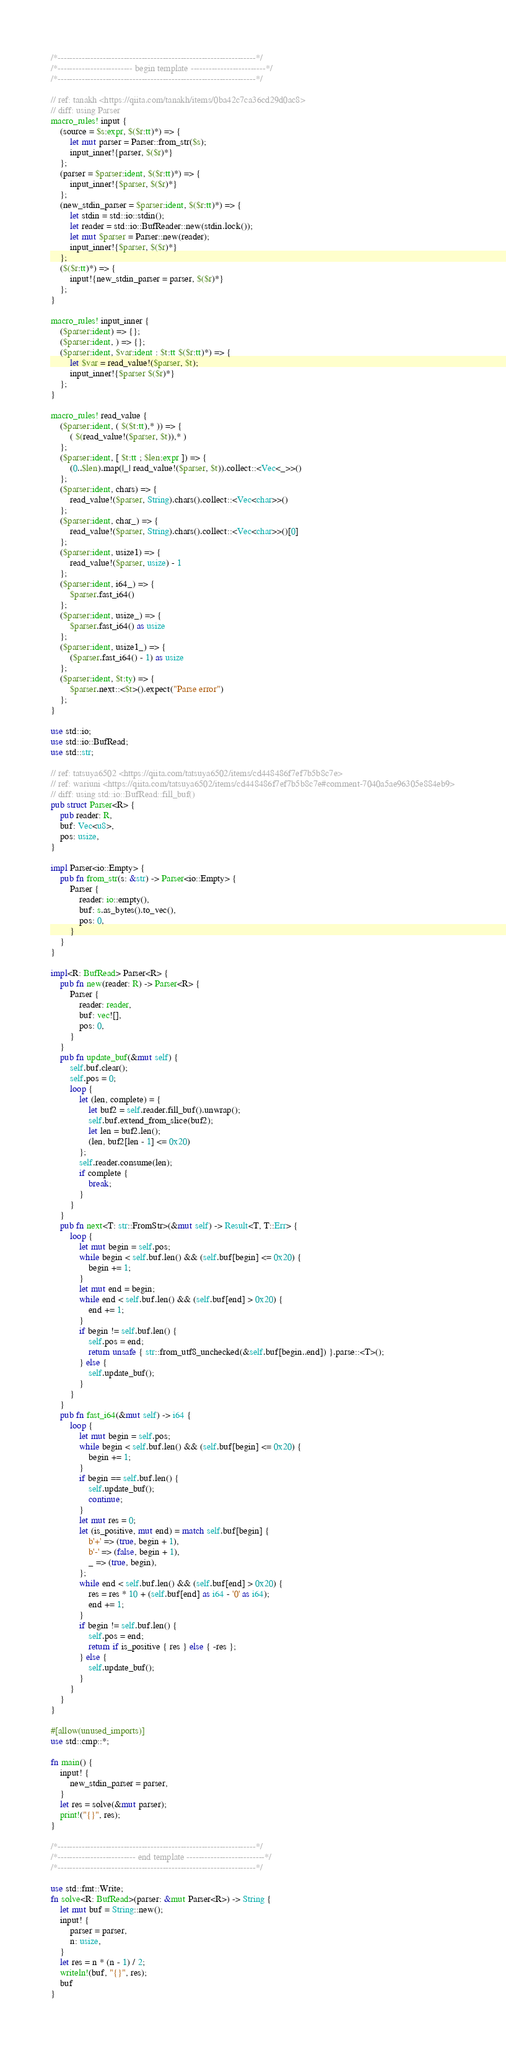Convert code to text. <code><loc_0><loc_0><loc_500><loc_500><_Rust_>/*------------------------------------------------------------------*/
/*------------------------- begin template -------------------------*/
/*------------------------------------------------------------------*/

// ref: tanakh <https://qiita.com/tanakh/items/0ba42c7ca36cd29d0ac8>
// diff: using Parser
macro_rules! input {
    (source = $s:expr, $($r:tt)*) => {
        let mut parser = Parser::from_str($s);
        input_inner!{parser, $($r)*}
    };
    (parser = $parser:ident, $($r:tt)*) => {
        input_inner!{$parser, $($r)*}
    };
    (new_stdin_parser = $parser:ident, $($r:tt)*) => {
        let stdin = std::io::stdin();
        let reader = std::io::BufReader::new(stdin.lock());
        let mut $parser = Parser::new(reader);
        input_inner!{$parser, $($r)*}
    };
    ($($r:tt)*) => {
        input!{new_stdin_parser = parser, $($r)*}
    };
}

macro_rules! input_inner {
    ($parser:ident) => {};
    ($parser:ident, ) => {};
    ($parser:ident, $var:ident : $t:tt $($r:tt)*) => {
        let $var = read_value!($parser, $t);
        input_inner!{$parser $($r)*}
    };
}

macro_rules! read_value {
    ($parser:ident, ( $($t:tt),* )) => {
        ( $(read_value!($parser, $t)),* )
    };
    ($parser:ident, [ $t:tt ; $len:expr ]) => {
        (0..$len).map(|_| read_value!($parser, $t)).collect::<Vec<_>>()
    };
    ($parser:ident, chars) => {
        read_value!($parser, String).chars().collect::<Vec<char>>()
    };
    ($parser:ident, char_) => {
        read_value!($parser, String).chars().collect::<Vec<char>>()[0]
    };
    ($parser:ident, usize1) => {
        read_value!($parser, usize) - 1
    };
    ($parser:ident, i64_) => {
        $parser.fast_i64()
    };
    ($parser:ident, usize_) => {
        $parser.fast_i64() as usize
    };
    ($parser:ident, usize1_) => {
        ($parser.fast_i64() - 1) as usize
    };
    ($parser:ident, $t:ty) => {
        $parser.next::<$t>().expect("Parse error")
    };
}

use std::io;
use std::io::BufRead;
use std::str;

// ref: tatsuya6502 <https://qiita.com/tatsuya6502/items/cd448486f7ef7b5b8c7e>
// ref: wariuni <https://qiita.com/tatsuya6502/items/cd448486f7ef7b5b8c7e#comment-7040a5ae96305e884eb9>
// diff: using std::io::BufRead::fill_buf()
pub struct Parser<R> {
    pub reader: R,
    buf: Vec<u8>,
    pos: usize,
}

impl Parser<io::Empty> {
    pub fn from_str(s: &str) -> Parser<io::Empty> {
        Parser {
            reader: io::empty(),
            buf: s.as_bytes().to_vec(),
            pos: 0,
        }
    }
}

impl<R: BufRead> Parser<R> {
    pub fn new(reader: R) -> Parser<R> {
        Parser {
            reader: reader,
            buf: vec![],
            pos: 0,
        }
    }
    pub fn update_buf(&mut self) {
        self.buf.clear();
        self.pos = 0;
        loop {
            let (len, complete) = {
                let buf2 = self.reader.fill_buf().unwrap();
                self.buf.extend_from_slice(buf2);
                let len = buf2.len();
                (len, buf2[len - 1] <= 0x20)
            };
            self.reader.consume(len);
            if complete {
                break;
            }
        }
    }
    pub fn next<T: str::FromStr>(&mut self) -> Result<T, T::Err> {
        loop {
            let mut begin = self.pos;
            while begin < self.buf.len() && (self.buf[begin] <= 0x20) {
                begin += 1;
            }
            let mut end = begin;
            while end < self.buf.len() && (self.buf[end] > 0x20) {
                end += 1;
            }
            if begin != self.buf.len() {
                self.pos = end;
                return unsafe { str::from_utf8_unchecked(&self.buf[begin..end]) }.parse::<T>();
            } else {
                self.update_buf();
            }
        }
    }
    pub fn fast_i64(&mut self) -> i64 {
        loop {
            let mut begin = self.pos;
            while begin < self.buf.len() && (self.buf[begin] <= 0x20) {
                begin += 1;
            }
            if begin == self.buf.len() {
                self.update_buf();
                continue;
            }
            let mut res = 0;
            let (is_positive, mut end) = match self.buf[begin] {
                b'+' => (true, begin + 1),
                b'-' => (false, begin + 1),
                _ => (true, begin),
            };
            while end < self.buf.len() && (self.buf[end] > 0x20) {
                res = res * 10 + (self.buf[end] as i64 - '0' as i64);
                end += 1;
            }
            if begin != self.buf.len() {
                self.pos = end;
                return if is_positive { res } else { -res };
            } else {
                self.update_buf();
            }
        }
    }
}

#[allow(unused_imports)]
use std::cmp::*;

fn main() {
    input! {
        new_stdin_parser = parser,
    }
    let res = solve(&mut parser);
    print!("{}", res);
}

/*------------------------------------------------------------------*/
/*-------------------------- end template --------------------------*/
/*------------------------------------------------------------------*/

use std::fmt::Write;
fn solve<R: BufRead>(parser: &mut Parser<R>) -> String {
    let mut buf = String::new();
    input! {
        parser = parser,
        n: usize,
    }
    let res = n * (n - 1) / 2;
    writeln!(buf, "{}", res);
    buf
}
</code> 